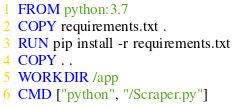Convert code to text. <code><loc_0><loc_0><loc_500><loc_500><_Dockerfile_>FROM python:3.7
COPY requirements.txt .
RUN pip install -r requirements.txt
COPY . .
WORKDIR /app
CMD ["python", "/Scraper.py"]
</code> 